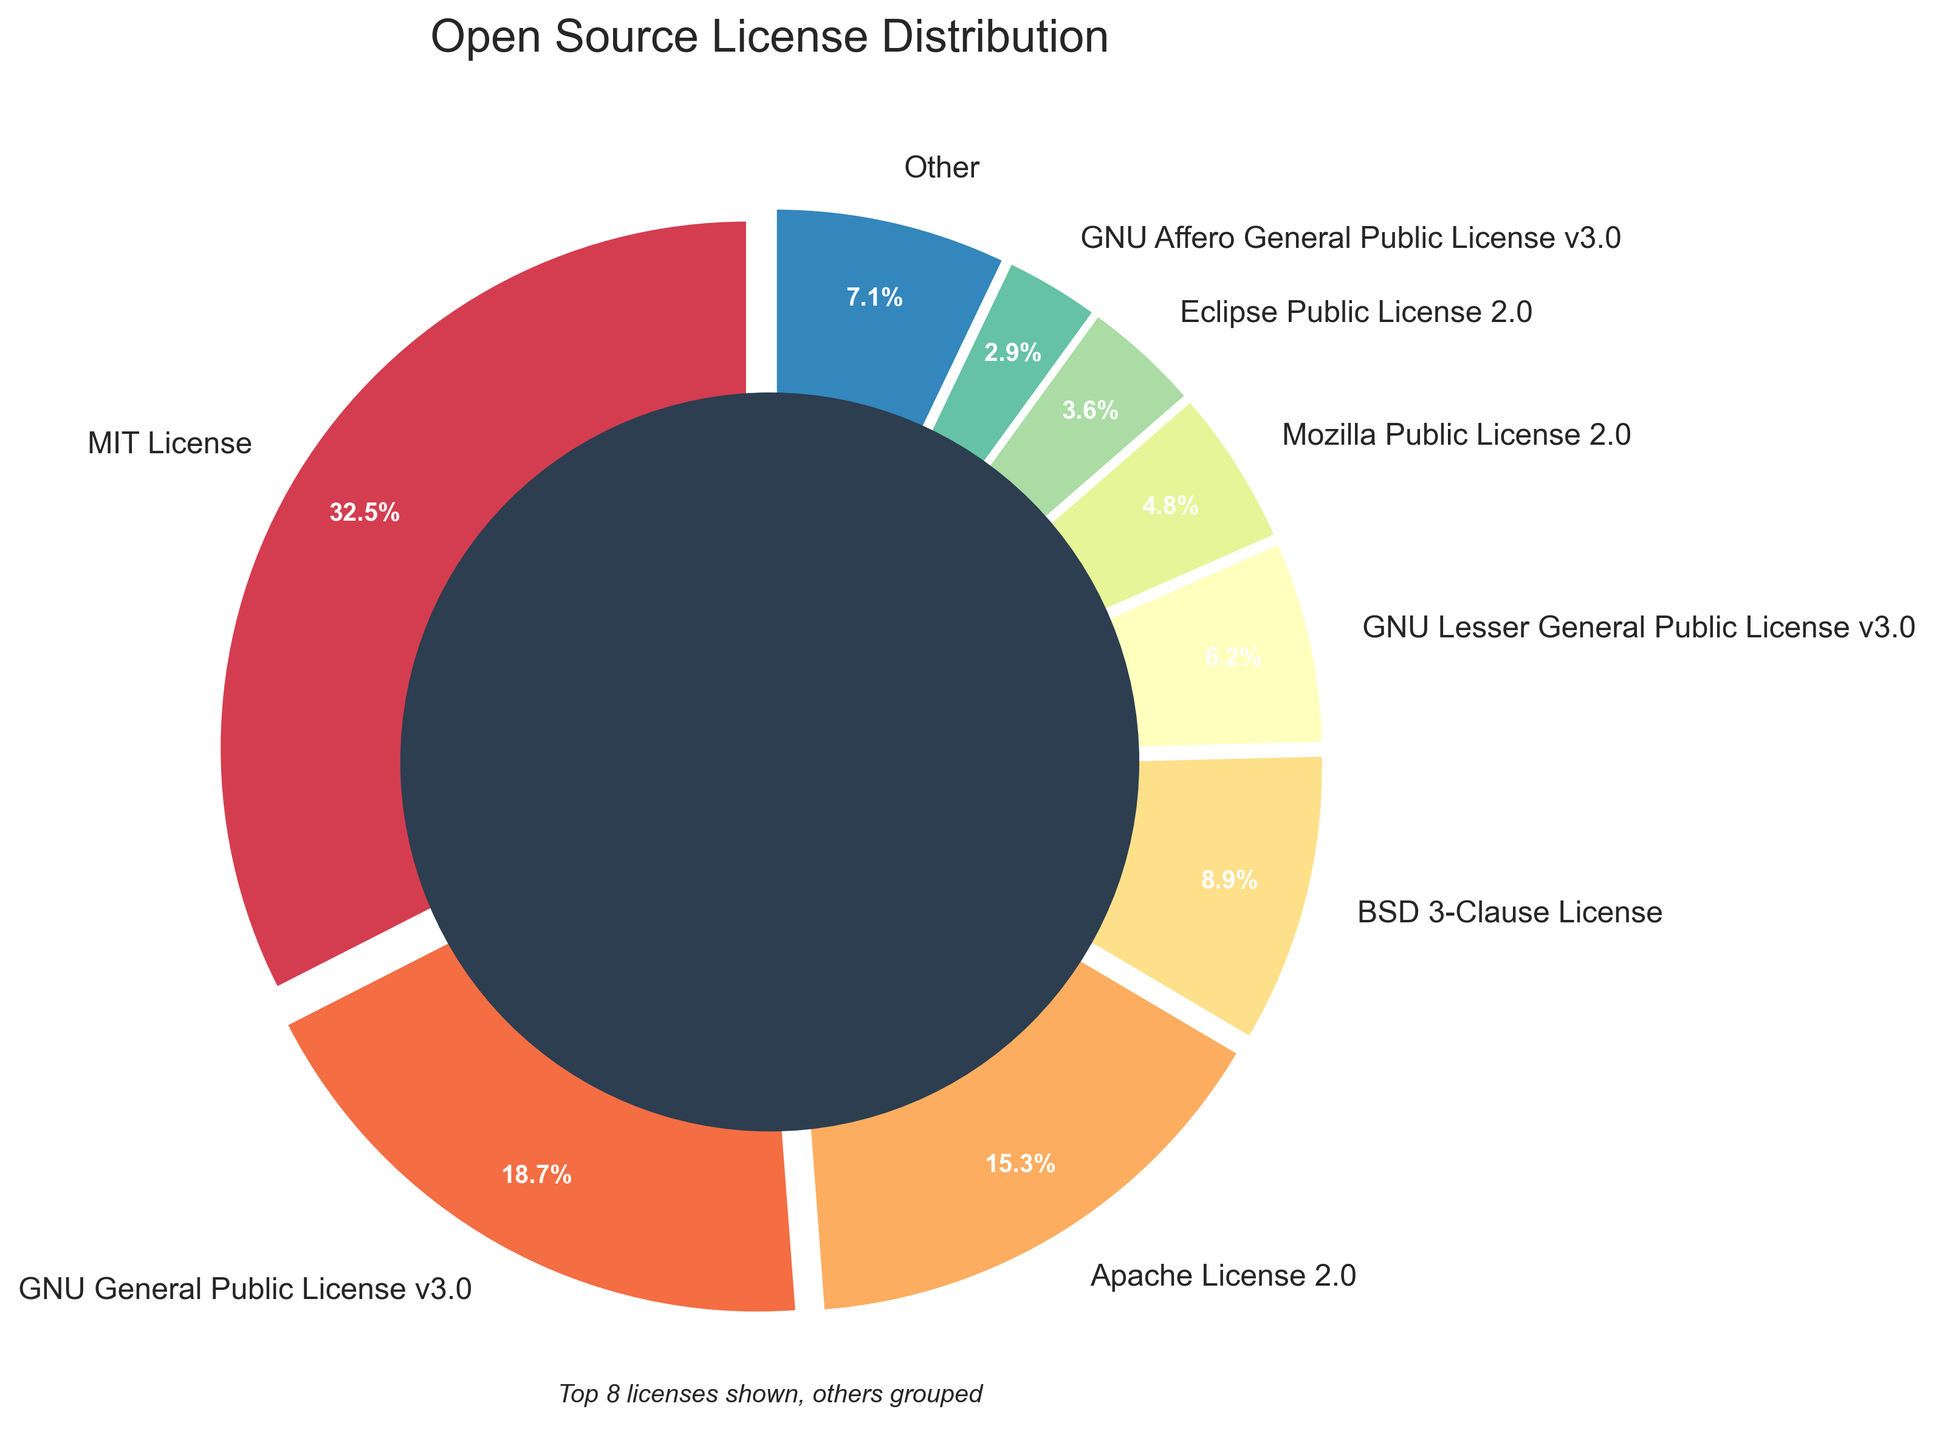Which license type has the largest percentage? Observe the slices in the pie chart and find the slice with the highest percentage. The MIT License slice is the largest.
Answer: MIT License Which license type has the smallest percentage among the top 8 shown? Look at the percentages listed next to each license in the top 8 slices of the pie chart. The Eclipse Public License 2.0 has the smallest percentage.
Answer: Eclipse Public License 2.0 What is the combined percentage of the top three license types? Add the percentages of the top three licenses: MIT License (32.5%), GNU General Public License v3.0 (18.7%), and Apache License 2.0 (15.3%). The sum is 32.5 + 18.7 + 15.3 = 66.5%.
Answer: 66.5% How does the percentage for Apache License 2.0 compare to that of BSD 3-Clause License? Compare the percentages of the two licenses. The Apache License 2.0 is 15.3% while the BSD 3-Clause License is 8.9%. The Apache License 2.0 is larger.
Answer: Apache License 2.0 What is the total percentage of the licenses grouped under 'Other'? From the pie chart, ‘Other’ represents all licenses not in the top 8. The 'Other' percentage is displayed directly on the pie chart.
Answer: 11.3% Is the percentage of GNU Affero General Public License v3.0 greater than that of Microsoft Public License? Compare the percentages of the two licenses. The GNU Affero General Public License v3.0 is 2.9% and the Microsoft Public License is 1.8%. The former is larger.
Answer: Yes What is the average percentage for the top 4 license types presented? Add the percentages of the top 4 licenses: 32.5% + 18.7% + 15.3% + 8.9%. The sum is 75.4%. Dividing by 4 gives 75.4 / 4 = 18.85%.
Answer: 18.85% Which license types occupy slices with a lighter color in the pie chart? Observing the color gradient in the pie chart, the lighter colors are towards the higher indices. This typically corresponds to the licenses with the lower percentages. In this case, it's likely some of the lower top 8 or grouped under 'Other'.
Answer: Eclipse Public License 2.0 and other smaller percentages Are there more licenses with a percentage higher than or equal to 10% or less than 10%? Count the number of licenses with greater than or equal to 10% and those with less than 10% among the top 8. Two licenses (MIT License and GNU General Public License v3.0) have percentages above or equal to 10%, while six have less.
Answer: Less than 10% 